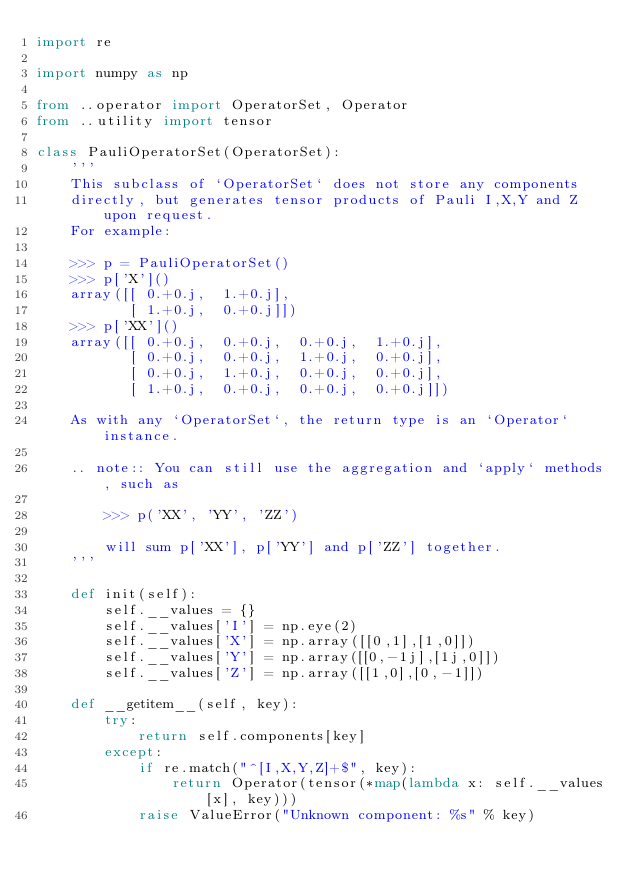Convert code to text. <code><loc_0><loc_0><loc_500><loc_500><_Python_>import re

import numpy as np

from ..operator import OperatorSet, Operator
from ..utility import tensor

class PauliOperatorSet(OperatorSet):
    '''
    This subclass of `OperatorSet` does not store any components
    directly, but generates tensor products of Pauli I,X,Y and Z upon request. 
    For example:
    
    >>> p = PauliOperatorSet()
    >>> p['X']()
    array([[ 0.+0.j,  1.+0.j],
           [ 1.+0.j,  0.+0.j]])
    >>> p['XX']()
    array([[ 0.+0.j,  0.+0.j,  0.+0.j,  1.+0.j],
           [ 0.+0.j,  0.+0.j,  1.+0.j,  0.+0.j],
           [ 0.+0.j,  1.+0.j,  0.+0.j,  0.+0.j],
           [ 1.+0.j,  0.+0.j,  0.+0.j,  0.+0.j]])
    
    As with any `OperatorSet`, the return type is an `Operator` instance.
    
    .. note:: You can still use the aggregation and `apply` methods, such as
        
        >>> p('XX', 'YY', 'ZZ')
        
        will sum p['XX'], p['YY'] and p['ZZ'] together.
    '''
    
    def init(self):
        self.__values = {}
        self.__values['I'] = np.eye(2)
        self.__values['X'] = np.array([[0,1],[1,0]])
        self.__values['Y'] = np.array([[0,-1j],[1j,0]])
        self.__values['Z'] = np.array([[1,0],[0,-1]])

    def __getitem__(self, key):
        try:
            return self.components[key]
        except:
            if re.match("^[I,X,Y,Z]+$", key):
                return Operator(tensor(*map(lambda x: self.__values[x], key)))
            raise ValueError("Unknown component: %s" % key)</code> 